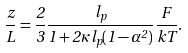<formula> <loc_0><loc_0><loc_500><loc_500>\frac { z } L = \frac { 2 } 3 \frac { l _ { p } } { 1 + 2 \kappa l _ { p } ( 1 - \alpha ^ { 2 } ) } \frac { F } { k T } .</formula> 